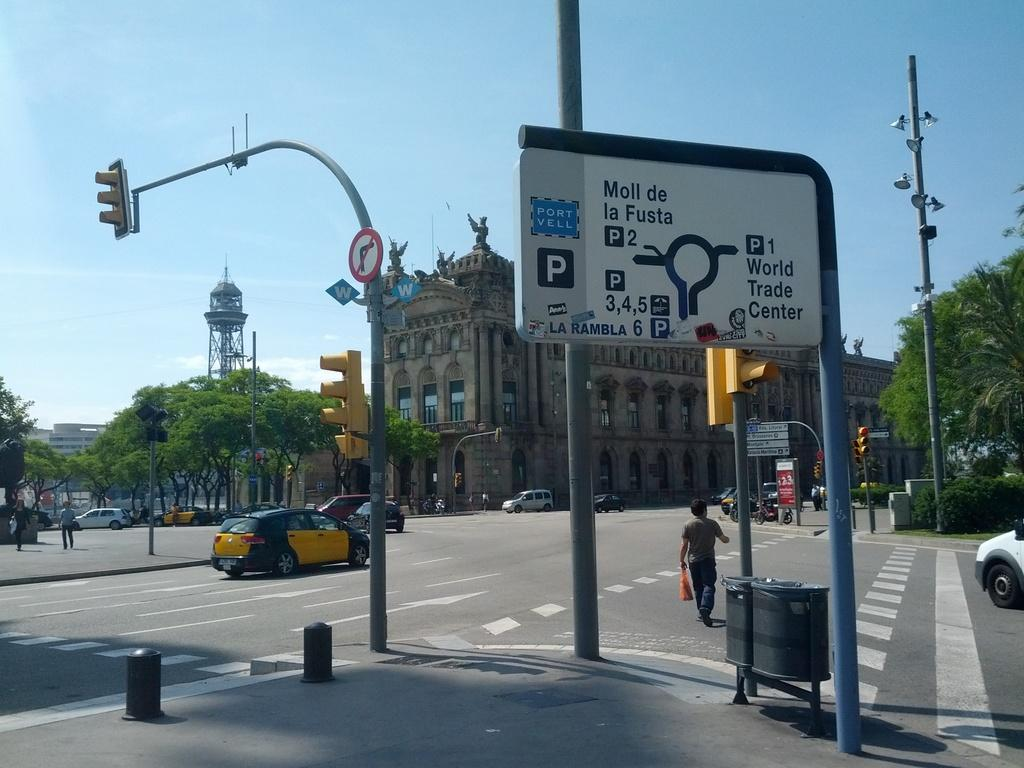Provide a one-sentence caption for the provided image. A parking information sign indicates a World Trade Center to the right. 